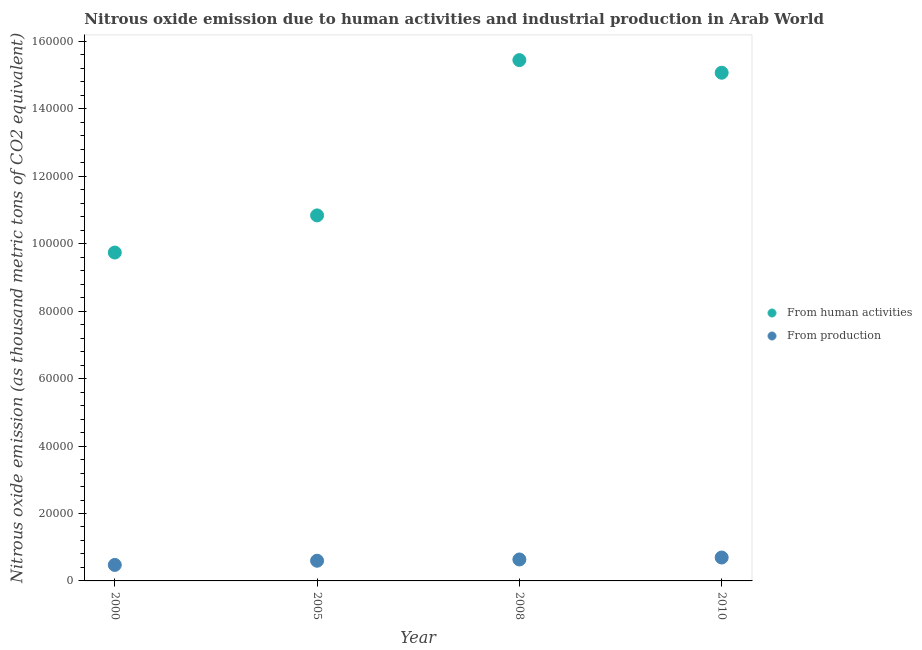How many different coloured dotlines are there?
Keep it short and to the point. 2. Is the number of dotlines equal to the number of legend labels?
Ensure brevity in your answer.  Yes. What is the amount of emissions generated from industries in 2005?
Offer a very short reply. 5989.1. Across all years, what is the maximum amount of emissions from human activities?
Make the answer very short. 1.54e+05. Across all years, what is the minimum amount of emissions from human activities?
Ensure brevity in your answer.  9.74e+04. In which year was the amount of emissions from human activities minimum?
Offer a very short reply. 2000. What is the total amount of emissions from human activities in the graph?
Keep it short and to the point. 5.11e+05. What is the difference between the amount of emissions generated from industries in 2005 and that in 2008?
Your response must be concise. -379. What is the difference between the amount of emissions from human activities in 2010 and the amount of emissions generated from industries in 2005?
Your response must be concise. 1.45e+05. What is the average amount of emissions generated from industries per year?
Your answer should be very brief. 6010.73. In the year 2005, what is the difference between the amount of emissions generated from industries and amount of emissions from human activities?
Ensure brevity in your answer.  -1.02e+05. What is the ratio of the amount of emissions from human activities in 2008 to that in 2010?
Make the answer very short. 1.02. Is the amount of emissions generated from industries in 2000 less than that in 2008?
Your answer should be very brief. Yes. Is the difference between the amount of emissions from human activities in 2008 and 2010 greater than the difference between the amount of emissions generated from industries in 2008 and 2010?
Provide a short and direct response. Yes. What is the difference between the highest and the second highest amount of emissions generated from industries?
Provide a succinct answer. 572.1. What is the difference between the highest and the lowest amount of emissions from human activities?
Your answer should be compact. 5.71e+04. In how many years, is the amount of emissions generated from industries greater than the average amount of emissions generated from industries taken over all years?
Your response must be concise. 2. Is the amount of emissions from human activities strictly less than the amount of emissions generated from industries over the years?
Offer a terse response. No. What is the difference between two consecutive major ticks on the Y-axis?
Keep it short and to the point. 2.00e+04. Are the values on the major ticks of Y-axis written in scientific E-notation?
Your answer should be compact. No. Does the graph contain grids?
Your answer should be very brief. No. Where does the legend appear in the graph?
Provide a short and direct response. Center right. How many legend labels are there?
Provide a short and direct response. 2. How are the legend labels stacked?
Your answer should be very brief. Vertical. What is the title of the graph?
Your response must be concise. Nitrous oxide emission due to human activities and industrial production in Arab World. What is the label or title of the Y-axis?
Your answer should be very brief. Nitrous oxide emission (as thousand metric tons of CO2 equivalent). What is the Nitrous oxide emission (as thousand metric tons of CO2 equivalent) in From human activities in 2000?
Make the answer very short. 9.74e+04. What is the Nitrous oxide emission (as thousand metric tons of CO2 equivalent) of From production in 2000?
Give a very brief answer. 4745.5. What is the Nitrous oxide emission (as thousand metric tons of CO2 equivalent) in From human activities in 2005?
Make the answer very short. 1.08e+05. What is the Nitrous oxide emission (as thousand metric tons of CO2 equivalent) of From production in 2005?
Your answer should be compact. 5989.1. What is the Nitrous oxide emission (as thousand metric tons of CO2 equivalent) in From human activities in 2008?
Your response must be concise. 1.54e+05. What is the Nitrous oxide emission (as thousand metric tons of CO2 equivalent) of From production in 2008?
Provide a succinct answer. 6368.1. What is the Nitrous oxide emission (as thousand metric tons of CO2 equivalent) of From human activities in 2010?
Keep it short and to the point. 1.51e+05. What is the Nitrous oxide emission (as thousand metric tons of CO2 equivalent) in From production in 2010?
Give a very brief answer. 6940.2. Across all years, what is the maximum Nitrous oxide emission (as thousand metric tons of CO2 equivalent) of From human activities?
Offer a very short reply. 1.54e+05. Across all years, what is the maximum Nitrous oxide emission (as thousand metric tons of CO2 equivalent) in From production?
Provide a succinct answer. 6940.2. Across all years, what is the minimum Nitrous oxide emission (as thousand metric tons of CO2 equivalent) of From human activities?
Your answer should be very brief. 9.74e+04. Across all years, what is the minimum Nitrous oxide emission (as thousand metric tons of CO2 equivalent) of From production?
Keep it short and to the point. 4745.5. What is the total Nitrous oxide emission (as thousand metric tons of CO2 equivalent) of From human activities in the graph?
Provide a short and direct response. 5.11e+05. What is the total Nitrous oxide emission (as thousand metric tons of CO2 equivalent) of From production in the graph?
Offer a terse response. 2.40e+04. What is the difference between the Nitrous oxide emission (as thousand metric tons of CO2 equivalent) of From human activities in 2000 and that in 2005?
Offer a terse response. -1.10e+04. What is the difference between the Nitrous oxide emission (as thousand metric tons of CO2 equivalent) of From production in 2000 and that in 2005?
Ensure brevity in your answer.  -1243.6. What is the difference between the Nitrous oxide emission (as thousand metric tons of CO2 equivalent) in From human activities in 2000 and that in 2008?
Ensure brevity in your answer.  -5.71e+04. What is the difference between the Nitrous oxide emission (as thousand metric tons of CO2 equivalent) in From production in 2000 and that in 2008?
Offer a very short reply. -1622.6. What is the difference between the Nitrous oxide emission (as thousand metric tons of CO2 equivalent) of From human activities in 2000 and that in 2010?
Your answer should be compact. -5.33e+04. What is the difference between the Nitrous oxide emission (as thousand metric tons of CO2 equivalent) in From production in 2000 and that in 2010?
Ensure brevity in your answer.  -2194.7. What is the difference between the Nitrous oxide emission (as thousand metric tons of CO2 equivalent) in From human activities in 2005 and that in 2008?
Keep it short and to the point. -4.61e+04. What is the difference between the Nitrous oxide emission (as thousand metric tons of CO2 equivalent) of From production in 2005 and that in 2008?
Your response must be concise. -379. What is the difference between the Nitrous oxide emission (as thousand metric tons of CO2 equivalent) of From human activities in 2005 and that in 2010?
Give a very brief answer. -4.23e+04. What is the difference between the Nitrous oxide emission (as thousand metric tons of CO2 equivalent) of From production in 2005 and that in 2010?
Make the answer very short. -951.1. What is the difference between the Nitrous oxide emission (as thousand metric tons of CO2 equivalent) of From human activities in 2008 and that in 2010?
Your answer should be very brief. 3741.4. What is the difference between the Nitrous oxide emission (as thousand metric tons of CO2 equivalent) in From production in 2008 and that in 2010?
Offer a very short reply. -572.1. What is the difference between the Nitrous oxide emission (as thousand metric tons of CO2 equivalent) in From human activities in 2000 and the Nitrous oxide emission (as thousand metric tons of CO2 equivalent) in From production in 2005?
Give a very brief answer. 9.14e+04. What is the difference between the Nitrous oxide emission (as thousand metric tons of CO2 equivalent) of From human activities in 2000 and the Nitrous oxide emission (as thousand metric tons of CO2 equivalent) of From production in 2008?
Make the answer very short. 9.10e+04. What is the difference between the Nitrous oxide emission (as thousand metric tons of CO2 equivalent) of From human activities in 2000 and the Nitrous oxide emission (as thousand metric tons of CO2 equivalent) of From production in 2010?
Your answer should be very brief. 9.05e+04. What is the difference between the Nitrous oxide emission (as thousand metric tons of CO2 equivalent) of From human activities in 2005 and the Nitrous oxide emission (as thousand metric tons of CO2 equivalent) of From production in 2008?
Provide a succinct answer. 1.02e+05. What is the difference between the Nitrous oxide emission (as thousand metric tons of CO2 equivalent) in From human activities in 2005 and the Nitrous oxide emission (as thousand metric tons of CO2 equivalent) in From production in 2010?
Make the answer very short. 1.01e+05. What is the difference between the Nitrous oxide emission (as thousand metric tons of CO2 equivalent) in From human activities in 2008 and the Nitrous oxide emission (as thousand metric tons of CO2 equivalent) in From production in 2010?
Give a very brief answer. 1.48e+05. What is the average Nitrous oxide emission (as thousand metric tons of CO2 equivalent) in From human activities per year?
Your answer should be compact. 1.28e+05. What is the average Nitrous oxide emission (as thousand metric tons of CO2 equivalent) of From production per year?
Your response must be concise. 6010.73. In the year 2000, what is the difference between the Nitrous oxide emission (as thousand metric tons of CO2 equivalent) of From human activities and Nitrous oxide emission (as thousand metric tons of CO2 equivalent) of From production?
Make the answer very short. 9.27e+04. In the year 2005, what is the difference between the Nitrous oxide emission (as thousand metric tons of CO2 equivalent) of From human activities and Nitrous oxide emission (as thousand metric tons of CO2 equivalent) of From production?
Your answer should be very brief. 1.02e+05. In the year 2008, what is the difference between the Nitrous oxide emission (as thousand metric tons of CO2 equivalent) in From human activities and Nitrous oxide emission (as thousand metric tons of CO2 equivalent) in From production?
Keep it short and to the point. 1.48e+05. In the year 2010, what is the difference between the Nitrous oxide emission (as thousand metric tons of CO2 equivalent) of From human activities and Nitrous oxide emission (as thousand metric tons of CO2 equivalent) of From production?
Provide a succinct answer. 1.44e+05. What is the ratio of the Nitrous oxide emission (as thousand metric tons of CO2 equivalent) in From human activities in 2000 to that in 2005?
Provide a succinct answer. 0.9. What is the ratio of the Nitrous oxide emission (as thousand metric tons of CO2 equivalent) in From production in 2000 to that in 2005?
Make the answer very short. 0.79. What is the ratio of the Nitrous oxide emission (as thousand metric tons of CO2 equivalent) of From human activities in 2000 to that in 2008?
Make the answer very short. 0.63. What is the ratio of the Nitrous oxide emission (as thousand metric tons of CO2 equivalent) of From production in 2000 to that in 2008?
Your response must be concise. 0.75. What is the ratio of the Nitrous oxide emission (as thousand metric tons of CO2 equivalent) of From human activities in 2000 to that in 2010?
Offer a terse response. 0.65. What is the ratio of the Nitrous oxide emission (as thousand metric tons of CO2 equivalent) in From production in 2000 to that in 2010?
Offer a terse response. 0.68. What is the ratio of the Nitrous oxide emission (as thousand metric tons of CO2 equivalent) in From human activities in 2005 to that in 2008?
Keep it short and to the point. 0.7. What is the ratio of the Nitrous oxide emission (as thousand metric tons of CO2 equivalent) of From production in 2005 to that in 2008?
Offer a terse response. 0.94. What is the ratio of the Nitrous oxide emission (as thousand metric tons of CO2 equivalent) of From human activities in 2005 to that in 2010?
Ensure brevity in your answer.  0.72. What is the ratio of the Nitrous oxide emission (as thousand metric tons of CO2 equivalent) of From production in 2005 to that in 2010?
Keep it short and to the point. 0.86. What is the ratio of the Nitrous oxide emission (as thousand metric tons of CO2 equivalent) in From human activities in 2008 to that in 2010?
Offer a terse response. 1.02. What is the ratio of the Nitrous oxide emission (as thousand metric tons of CO2 equivalent) of From production in 2008 to that in 2010?
Keep it short and to the point. 0.92. What is the difference between the highest and the second highest Nitrous oxide emission (as thousand metric tons of CO2 equivalent) in From human activities?
Offer a terse response. 3741.4. What is the difference between the highest and the second highest Nitrous oxide emission (as thousand metric tons of CO2 equivalent) of From production?
Provide a short and direct response. 572.1. What is the difference between the highest and the lowest Nitrous oxide emission (as thousand metric tons of CO2 equivalent) in From human activities?
Make the answer very short. 5.71e+04. What is the difference between the highest and the lowest Nitrous oxide emission (as thousand metric tons of CO2 equivalent) of From production?
Your response must be concise. 2194.7. 